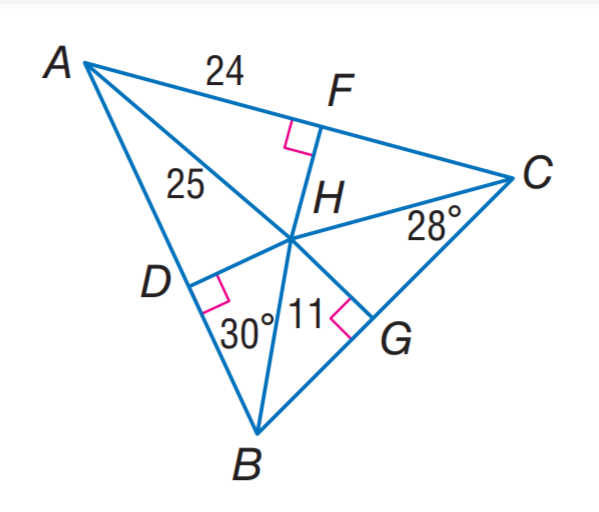Answer the mathemtical geometry problem and directly provide the correct option letter.
Question: H is the incenter of \triangle A B C. Find m \angle H A C.
Choices: A: 25 B: 28 C: 30 D: 32 D 